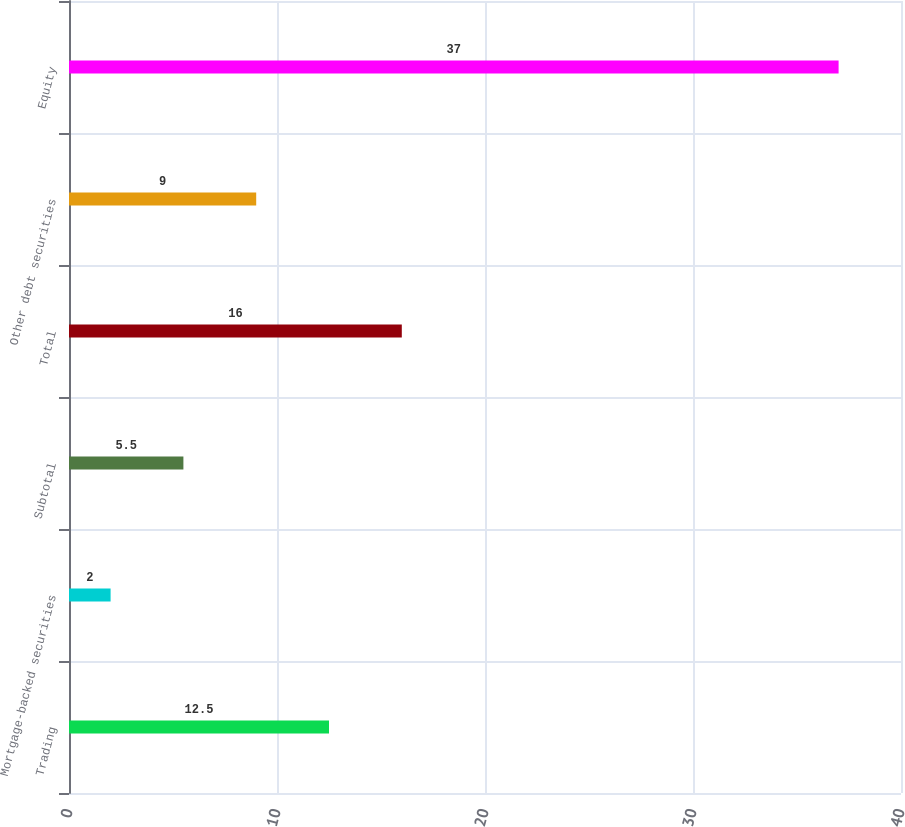Convert chart to OTSL. <chart><loc_0><loc_0><loc_500><loc_500><bar_chart><fcel>Trading<fcel>Mortgage-backed securities<fcel>Subtotal<fcel>Total<fcel>Other debt securities<fcel>Equity<nl><fcel>12.5<fcel>2<fcel>5.5<fcel>16<fcel>9<fcel>37<nl></chart> 